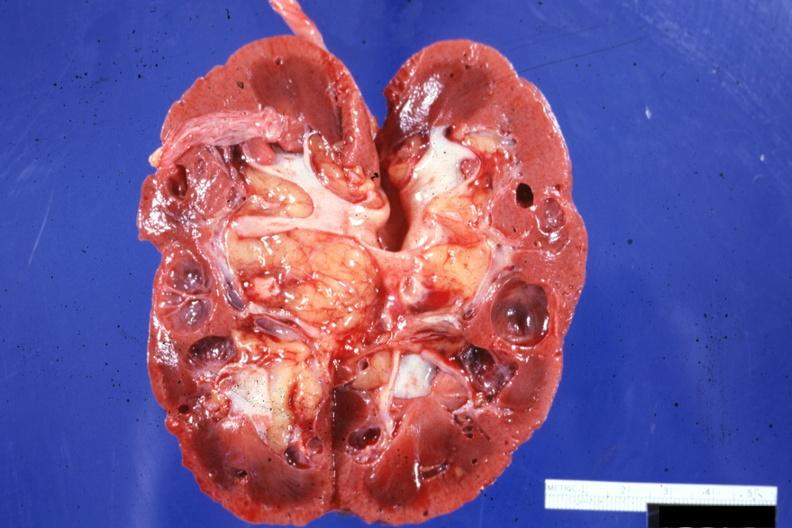s multiple cysts present?
Answer the question using a single word or phrase. Yes 